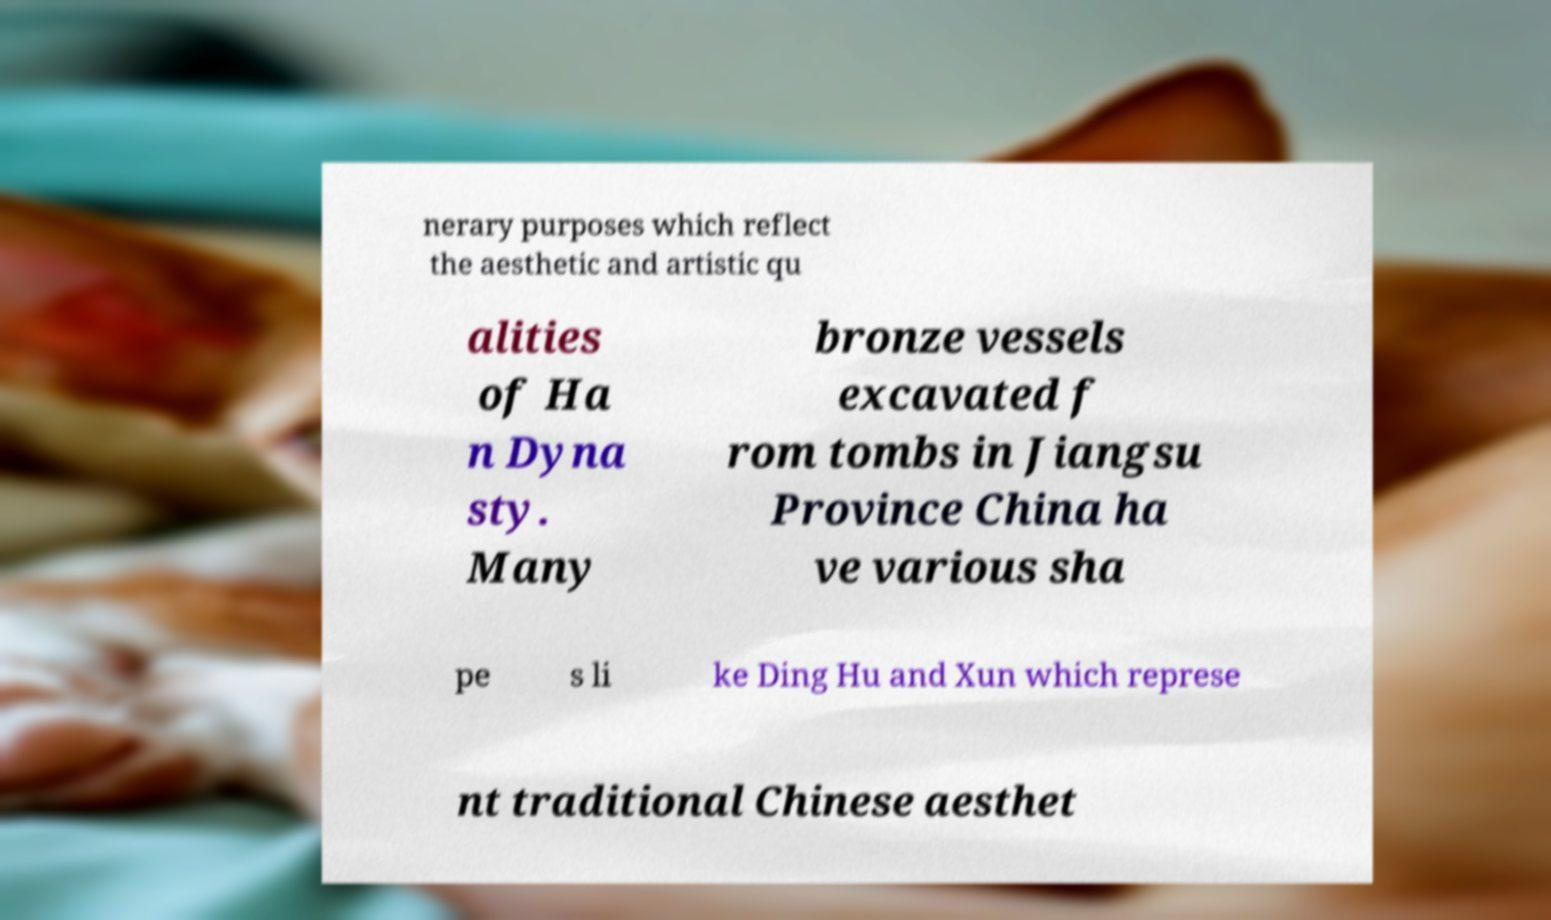Could you extract and type out the text from this image? nerary purposes which reflect the aesthetic and artistic qu alities of Ha n Dyna sty. Many bronze vessels excavated f rom tombs in Jiangsu Province China ha ve various sha pe s li ke Ding Hu and Xun which represe nt traditional Chinese aesthet 